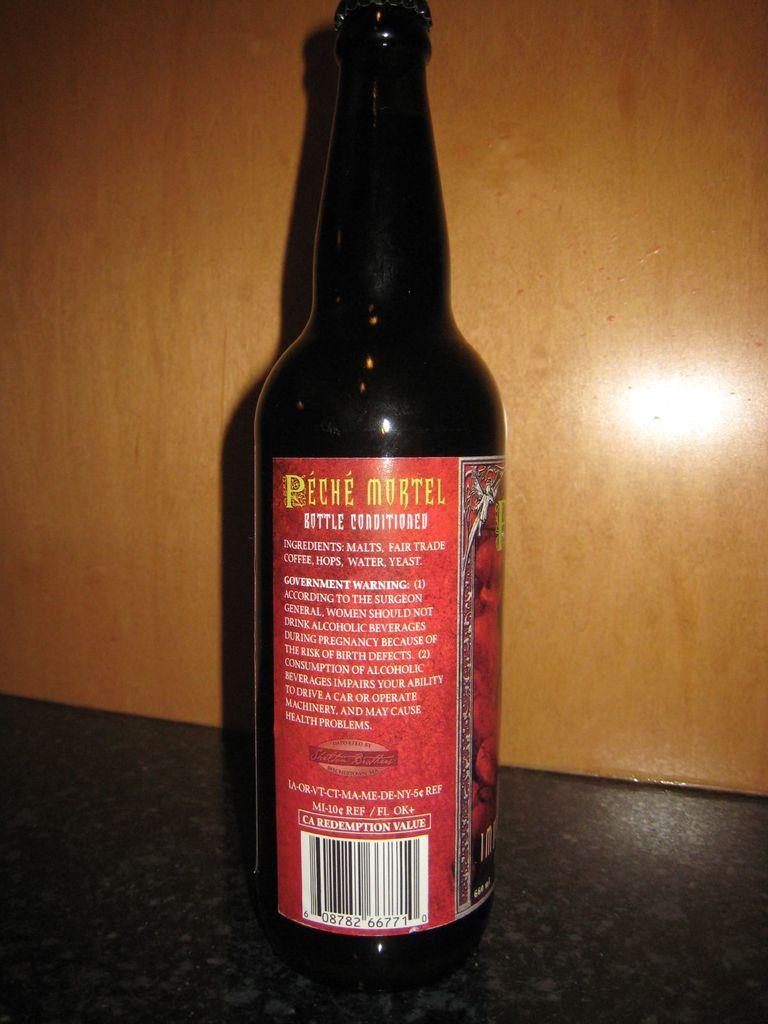In one or two sentences, can you explain what this image depicts? In this image we can see a bottle with sticker on it and in the background we can see the wall. 